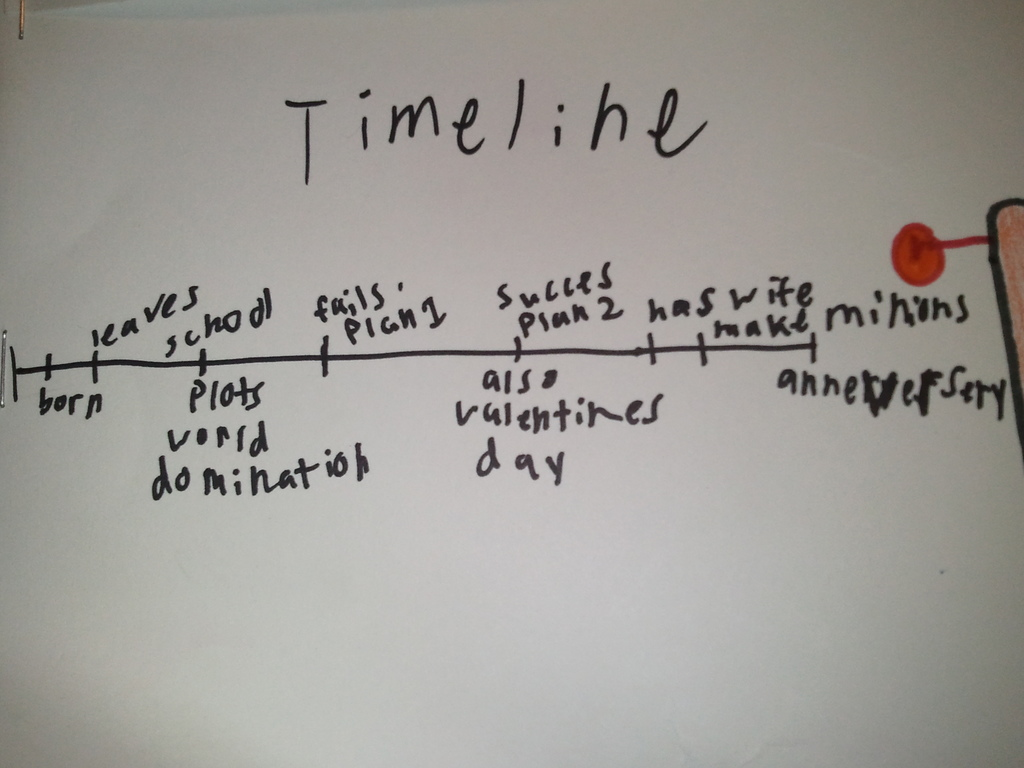What does the red pushpin on the timeline indicate? The red pushpin on the timeline likely serves a dual purpose. It may symbolize a current point in time or a significant moment that the timeline's creator wishes to mark, perhaps the 'anniversary.' Alternatively, it can be seen as a visual cue that the timeline is an ongoing story, suggesting that there are more events and milestones yet to come. The pushpin effectively invites viewers to consider both what has been documented and what future adventures might be added. 